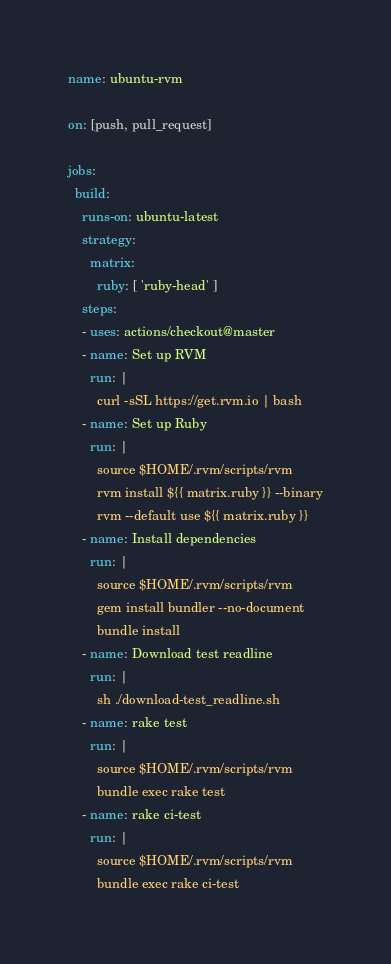<code> <loc_0><loc_0><loc_500><loc_500><_YAML_>name: ubuntu-rvm

on: [push, pull_request]

jobs:
  build:
    runs-on: ubuntu-latest
    strategy:
      matrix:
        ruby: [ 'ruby-head' ]
    steps:
    - uses: actions/checkout@master
    - name: Set up RVM
      run: |
        curl -sSL https://get.rvm.io | bash
    - name: Set up Ruby
      run: |
        source $HOME/.rvm/scripts/rvm
        rvm install ${{ matrix.ruby }} --binary
        rvm --default use ${{ matrix.ruby }}
    - name: Install dependencies
      run: |
        source $HOME/.rvm/scripts/rvm
        gem install bundler --no-document
        bundle install
    - name: Download test readline
      run: |
        sh ./download-test_readline.sh
    - name: rake test
      run: |
        source $HOME/.rvm/scripts/rvm
        bundle exec rake test
    - name: rake ci-test
      run: |
        source $HOME/.rvm/scripts/rvm
        bundle exec rake ci-test
</code> 